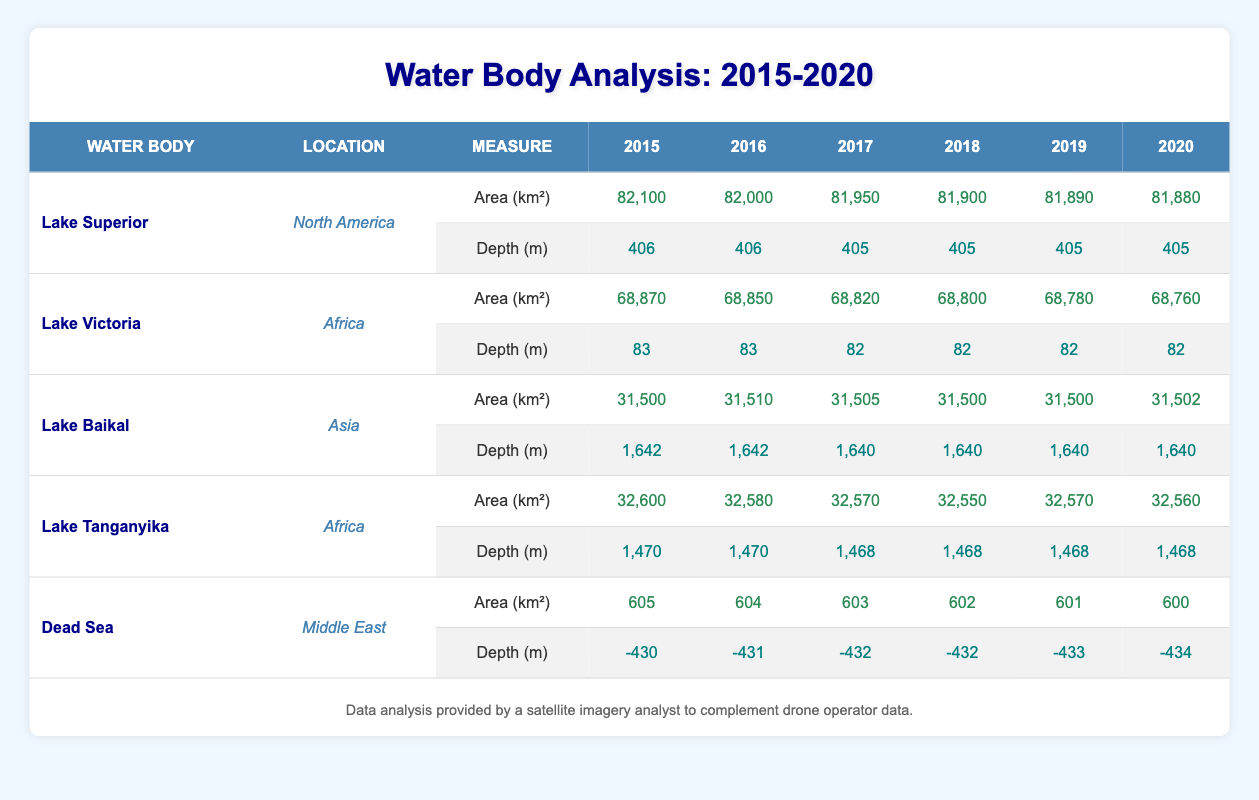What is the area of Lake Superior in 2015? The table lists the area of Lake Superior in 2015 as 82,100 square kilometers.
Answer: 82,100 sq km Which year had the lowest area for Lake Victoria? By examining the table, the lowest area for Lake Victoria occurred in 2020, with an area of 68,760 square kilometers.
Answer: 2020 Did Lake Baikal's area increase or decrease from 2015 to 2020? The table shows that Lake Baikal's area changed from 31,500 square kilometers in 2015 to 31,502 square kilometers in 2020, indicating a slight increase.
Answer: Increase What was the average area of Lake Tanganyika from 2015 to 2020? The areas from 2015 to 2020 are 32,600, 32,580, 32,570, 32,550, 32,570, and 32,560 square kilometers. Adding these gives 195,570. Dividing by 6 gives an average of 32,595 square kilometers.
Answer: 32,595 sq km Was the depth of the Dead Sea more negative in 2015 or 2020? The table indicates that the depth of the Dead Sea was -430 meters in 2015 and -434 meters in 2020. Since -434 is deeper than -430, it is more negative in 2020.
Answer: 2020 How much did the area of Lake Superior decrease from 2015 to 2020? The area of Lake Superior decreased from 82,100 square kilometers in 2015 to 81,880 square kilometers in 2020. The difference is 82,100 - 81,880 = 220 square kilometers.
Answer: 220 sq km Which lake retained the highest depth over the years recorded? The table shows that Lake Baikal consistently has the highest depth of 1,642 meters in 2015 and 2016, then drops slightly to 1,640 meters from 2017 to 2020.
Answer: Lake Baikal Has the area of the Dead Sea reached its lowest point by 2020? The table records the area of the Dead Sea decreasing each year, reaching the lowest recorded area of 600 square kilometers in 2020. In fact, prior years show larger areas: 605 in 2015 down to 600 in 2020, confirming it's the lowest.
Answer: Yes 